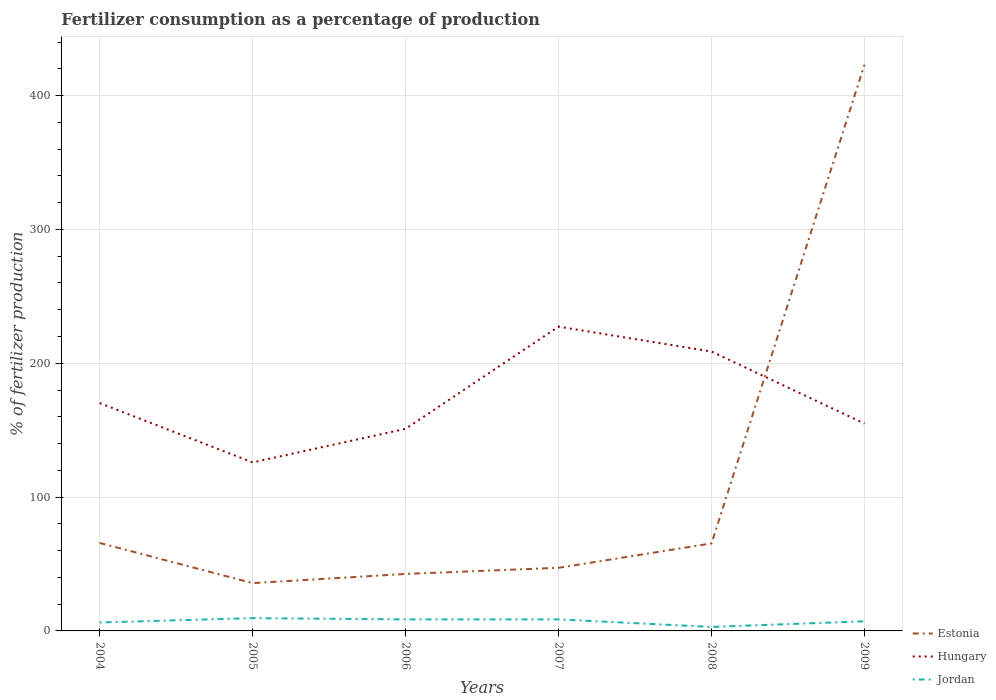How many different coloured lines are there?
Offer a very short reply. 3. Does the line corresponding to Jordan intersect with the line corresponding to Estonia?
Offer a terse response. No. Is the number of lines equal to the number of legend labels?
Provide a short and direct response. Yes. Across all years, what is the maximum percentage of fertilizers consumed in Estonia?
Offer a very short reply. 35.72. What is the total percentage of fertilizers consumed in Jordan in the graph?
Keep it short and to the point. -3.25. What is the difference between the highest and the second highest percentage of fertilizers consumed in Estonia?
Ensure brevity in your answer.  387.4. How many lines are there?
Provide a succinct answer. 3. What is the difference between two consecutive major ticks on the Y-axis?
Offer a very short reply. 100. Are the values on the major ticks of Y-axis written in scientific E-notation?
Your answer should be very brief. No. What is the title of the graph?
Keep it short and to the point. Fertilizer consumption as a percentage of production. Does "Egypt, Arab Rep." appear as one of the legend labels in the graph?
Make the answer very short. No. What is the label or title of the X-axis?
Your response must be concise. Years. What is the label or title of the Y-axis?
Offer a very short reply. % of fertilizer production. What is the % of fertilizer production of Estonia in 2004?
Offer a very short reply. 65.74. What is the % of fertilizer production of Hungary in 2004?
Keep it short and to the point. 170.26. What is the % of fertilizer production of Jordan in 2004?
Give a very brief answer. 6.31. What is the % of fertilizer production of Estonia in 2005?
Provide a short and direct response. 35.72. What is the % of fertilizer production in Hungary in 2005?
Your answer should be very brief. 125.92. What is the % of fertilizer production in Jordan in 2005?
Your answer should be very brief. 9.56. What is the % of fertilizer production in Estonia in 2006?
Your answer should be compact. 42.57. What is the % of fertilizer production of Hungary in 2006?
Your response must be concise. 150.99. What is the % of fertilizer production of Jordan in 2006?
Your answer should be very brief. 8.61. What is the % of fertilizer production in Estonia in 2007?
Offer a very short reply. 47.17. What is the % of fertilizer production of Hungary in 2007?
Keep it short and to the point. 227.39. What is the % of fertilizer production of Jordan in 2007?
Offer a very short reply. 8.6. What is the % of fertilizer production of Estonia in 2008?
Provide a succinct answer. 65.39. What is the % of fertilizer production in Hungary in 2008?
Provide a succinct answer. 208.76. What is the % of fertilizer production of Jordan in 2008?
Provide a succinct answer. 2.99. What is the % of fertilizer production in Estonia in 2009?
Your answer should be very brief. 423.12. What is the % of fertilizer production of Hungary in 2009?
Give a very brief answer. 154.95. What is the % of fertilizer production of Jordan in 2009?
Your response must be concise. 7.18. Across all years, what is the maximum % of fertilizer production of Estonia?
Your response must be concise. 423.12. Across all years, what is the maximum % of fertilizer production of Hungary?
Make the answer very short. 227.39. Across all years, what is the maximum % of fertilizer production in Jordan?
Offer a terse response. 9.56. Across all years, what is the minimum % of fertilizer production in Estonia?
Keep it short and to the point. 35.72. Across all years, what is the minimum % of fertilizer production in Hungary?
Offer a very short reply. 125.92. Across all years, what is the minimum % of fertilizer production of Jordan?
Provide a short and direct response. 2.99. What is the total % of fertilizer production of Estonia in the graph?
Provide a short and direct response. 679.71. What is the total % of fertilizer production of Hungary in the graph?
Your answer should be compact. 1038.27. What is the total % of fertilizer production in Jordan in the graph?
Offer a terse response. 43.25. What is the difference between the % of fertilizer production in Estonia in 2004 and that in 2005?
Provide a succinct answer. 30.02. What is the difference between the % of fertilizer production in Hungary in 2004 and that in 2005?
Your response must be concise. 44.33. What is the difference between the % of fertilizer production in Jordan in 2004 and that in 2005?
Your answer should be compact. -3.25. What is the difference between the % of fertilizer production of Estonia in 2004 and that in 2006?
Your answer should be very brief. 23.16. What is the difference between the % of fertilizer production in Hungary in 2004 and that in 2006?
Your response must be concise. 19.26. What is the difference between the % of fertilizer production in Jordan in 2004 and that in 2006?
Make the answer very short. -2.3. What is the difference between the % of fertilizer production of Estonia in 2004 and that in 2007?
Your response must be concise. 18.57. What is the difference between the % of fertilizer production in Hungary in 2004 and that in 2007?
Your response must be concise. -57.13. What is the difference between the % of fertilizer production of Jordan in 2004 and that in 2007?
Ensure brevity in your answer.  -2.29. What is the difference between the % of fertilizer production in Estonia in 2004 and that in 2008?
Provide a short and direct response. 0.35. What is the difference between the % of fertilizer production in Hungary in 2004 and that in 2008?
Ensure brevity in your answer.  -38.5. What is the difference between the % of fertilizer production of Jordan in 2004 and that in 2008?
Your response must be concise. 3.32. What is the difference between the % of fertilizer production in Estonia in 2004 and that in 2009?
Keep it short and to the point. -357.38. What is the difference between the % of fertilizer production of Hungary in 2004 and that in 2009?
Provide a short and direct response. 15.3. What is the difference between the % of fertilizer production of Jordan in 2004 and that in 2009?
Offer a terse response. -0.87. What is the difference between the % of fertilizer production in Estonia in 2005 and that in 2006?
Offer a terse response. -6.86. What is the difference between the % of fertilizer production of Hungary in 2005 and that in 2006?
Your answer should be compact. -25.07. What is the difference between the % of fertilizer production of Jordan in 2005 and that in 2006?
Make the answer very short. 0.94. What is the difference between the % of fertilizer production of Estonia in 2005 and that in 2007?
Give a very brief answer. -11.45. What is the difference between the % of fertilizer production of Hungary in 2005 and that in 2007?
Provide a succinct answer. -101.46. What is the difference between the % of fertilizer production in Jordan in 2005 and that in 2007?
Offer a terse response. 0.95. What is the difference between the % of fertilizer production in Estonia in 2005 and that in 2008?
Keep it short and to the point. -29.67. What is the difference between the % of fertilizer production of Hungary in 2005 and that in 2008?
Your response must be concise. -82.83. What is the difference between the % of fertilizer production of Jordan in 2005 and that in 2008?
Ensure brevity in your answer.  6.56. What is the difference between the % of fertilizer production in Estonia in 2005 and that in 2009?
Provide a succinct answer. -387.4. What is the difference between the % of fertilizer production of Hungary in 2005 and that in 2009?
Offer a terse response. -29.03. What is the difference between the % of fertilizer production in Jordan in 2005 and that in 2009?
Make the answer very short. 2.38. What is the difference between the % of fertilizer production in Estonia in 2006 and that in 2007?
Offer a terse response. -4.59. What is the difference between the % of fertilizer production of Hungary in 2006 and that in 2007?
Provide a succinct answer. -76.39. What is the difference between the % of fertilizer production in Jordan in 2006 and that in 2007?
Provide a succinct answer. 0.01. What is the difference between the % of fertilizer production of Estonia in 2006 and that in 2008?
Provide a short and direct response. -22.82. What is the difference between the % of fertilizer production in Hungary in 2006 and that in 2008?
Provide a short and direct response. -57.76. What is the difference between the % of fertilizer production in Jordan in 2006 and that in 2008?
Offer a very short reply. 5.62. What is the difference between the % of fertilizer production of Estonia in 2006 and that in 2009?
Ensure brevity in your answer.  -380.54. What is the difference between the % of fertilizer production in Hungary in 2006 and that in 2009?
Provide a short and direct response. -3.96. What is the difference between the % of fertilizer production in Jordan in 2006 and that in 2009?
Your response must be concise. 1.43. What is the difference between the % of fertilizer production of Estonia in 2007 and that in 2008?
Your answer should be very brief. -18.23. What is the difference between the % of fertilizer production in Hungary in 2007 and that in 2008?
Your answer should be very brief. 18.63. What is the difference between the % of fertilizer production of Jordan in 2007 and that in 2008?
Provide a short and direct response. 5.61. What is the difference between the % of fertilizer production of Estonia in 2007 and that in 2009?
Ensure brevity in your answer.  -375.95. What is the difference between the % of fertilizer production in Hungary in 2007 and that in 2009?
Provide a short and direct response. 72.43. What is the difference between the % of fertilizer production of Jordan in 2007 and that in 2009?
Keep it short and to the point. 1.42. What is the difference between the % of fertilizer production of Estonia in 2008 and that in 2009?
Offer a terse response. -357.73. What is the difference between the % of fertilizer production in Hungary in 2008 and that in 2009?
Offer a very short reply. 53.8. What is the difference between the % of fertilizer production in Jordan in 2008 and that in 2009?
Make the answer very short. -4.19. What is the difference between the % of fertilizer production in Estonia in 2004 and the % of fertilizer production in Hungary in 2005?
Provide a succinct answer. -60.19. What is the difference between the % of fertilizer production of Estonia in 2004 and the % of fertilizer production of Jordan in 2005?
Keep it short and to the point. 56.18. What is the difference between the % of fertilizer production in Hungary in 2004 and the % of fertilizer production in Jordan in 2005?
Ensure brevity in your answer.  160.7. What is the difference between the % of fertilizer production in Estonia in 2004 and the % of fertilizer production in Hungary in 2006?
Provide a succinct answer. -85.26. What is the difference between the % of fertilizer production in Estonia in 2004 and the % of fertilizer production in Jordan in 2006?
Keep it short and to the point. 57.12. What is the difference between the % of fertilizer production in Hungary in 2004 and the % of fertilizer production in Jordan in 2006?
Make the answer very short. 161.64. What is the difference between the % of fertilizer production in Estonia in 2004 and the % of fertilizer production in Hungary in 2007?
Provide a short and direct response. -161.65. What is the difference between the % of fertilizer production of Estonia in 2004 and the % of fertilizer production of Jordan in 2007?
Offer a terse response. 57.14. What is the difference between the % of fertilizer production in Hungary in 2004 and the % of fertilizer production in Jordan in 2007?
Provide a short and direct response. 161.65. What is the difference between the % of fertilizer production in Estonia in 2004 and the % of fertilizer production in Hungary in 2008?
Offer a terse response. -143.02. What is the difference between the % of fertilizer production in Estonia in 2004 and the % of fertilizer production in Jordan in 2008?
Your answer should be compact. 62.74. What is the difference between the % of fertilizer production in Hungary in 2004 and the % of fertilizer production in Jordan in 2008?
Give a very brief answer. 167.26. What is the difference between the % of fertilizer production in Estonia in 2004 and the % of fertilizer production in Hungary in 2009?
Keep it short and to the point. -89.21. What is the difference between the % of fertilizer production in Estonia in 2004 and the % of fertilizer production in Jordan in 2009?
Offer a very short reply. 58.56. What is the difference between the % of fertilizer production of Hungary in 2004 and the % of fertilizer production of Jordan in 2009?
Ensure brevity in your answer.  163.08. What is the difference between the % of fertilizer production of Estonia in 2005 and the % of fertilizer production of Hungary in 2006?
Your response must be concise. -115.27. What is the difference between the % of fertilizer production of Estonia in 2005 and the % of fertilizer production of Jordan in 2006?
Make the answer very short. 27.11. What is the difference between the % of fertilizer production of Hungary in 2005 and the % of fertilizer production of Jordan in 2006?
Make the answer very short. 117.31. What is the difference between the % of fertilizer production in Estonia in 2005 and the % of fertilizer production in Hungary in 2007?
Your response must be concise. -191.67. What is the difference between the % of fertilizer production of Estonia in 2005 and the % of fertilizer production of Jordan in 2007?
Make the answer very short. 27.12. What is the difference between the % of fertilizer production of Hungary in 2005 and the % of fertilizer production of Jordan in 2007?
Ensure brevity in your answer.  117.32. What is the difference between the % of fertilizer production in Estonia in 2005 and the % of fertilizer production in Hungary in 2008?
Offer a terse response. -173.04. What is the difference between the % of fertilizer production of Estonia in 2005 and the % of fertilizer production of Jordan in 2008?
Offer a terse response. 32.73. What is the difference between the % of fertilizer production in Hungary in 2005 and the % of fertilizer production in Jordan in 2008?
Your answer should be very brief. 122.93. What is the difference between the % of fertilizer production in Estonia in 2005 and the % of fertilizer production in Hungary in 2009?
Keep it short and to the point. -119.23. What is the difference between the % of fertilizer production in Estonia in 2005 and the % of fertilizer production in Jordan in 2009?
Your answer should be very brief. 28.54. What is the difference between the % of fertilizer production in Hungary in 2005 and the % of fertilizer production in Jordan in 2009?
Make the answer very short. 118.74. What is the difference between the % of fertilizer production of Estonia in 2006 and the % of fertilizer production of Hungary in 2007?
Offer a very short reply. -184.81. What is the difference between the % of fertilizer production of Estonia in 2006 and the % of fertilizer production of Jordan in 2007?
Make the answer very short. 33.97. What is the difference between the % of fertilizer production of Hungary in 2006 and the % of fertilizer production of Jordan in 2007?
Provide a succinct answer. 142.39. What is the difference between the % of fertilizer production in Estonia in 2006 and the % of fertilizer production in Hungary in 2008?
Make the answer very short. -166.18. What is the difference between the % of fertilizer production in Estonia in 2006 and the % of fertilizer production in Jordan in 2008?
Your response must be concise. 39.58. What is the difference between the % of fertilizer production in Hungary in 2006 and the % of fertilizer production in Jordan in 2008?
Provide a succinct answer. 148. What is the difference between the % of fertilizer production in Estonia in 2006 and the % of fertilizer production in Hungary in 2009?
Give a very brief answer. -112.38. What is the difference between the % of fertilizer production of Estonia in 2006 and the % of fertilizer production of Jordan in 2009?
Your answer should be very brief. 35.4. What is the difference between the % of fertilizer production of Hungary in 2006 and the % of fertilizer production of Jordan in 2009?
Provide a succinct answer. 143.81. What is the difference between the % of fertilizer production of Estonia in 2007 and the % of fertilizer production of Hungary in 2008?
Ensure brevity in your answer.  -161.59. What is the difference between the % of fertilizer production of Estonia in 2007 and the % of fertilizer production of Jordan in 2008?
Provide a succinct answer. 44.17. What is the difference between the % of fertilizer production in Hungary in 2007 and the % of fertilizer production in Jordan in 2008?
Offer a very short reply. 224.39. What is the difference between the % of fertilizer production in Estonia in 2007 and the % of fertilizer production in Hungary in 2009?
Ensure brevity in your answer.  -107.79. What is the difference between the % of fertilizer production in Estonia in 2007 and the % of fertilizer production in Jordan in 2009?
Make the answer very short. 39.99. What is the difference between the % of fertilizer production of Hungary in 2007 and the % of fertilizer production of Jordan in 2009?
Offer a very short reply. 220.21. What is the difference between the % of fertilizer production of Estonia in 2008 and the % of fertilizer production of Hungary in 2009?
Your response must be concise. -89.56. What is the difference between the % of fertilizer production of Estonia in 2008 and the % of fertilizer production of Jordan in 2009?
Your answer should be very brief. 58.21. What is the difference between the % of fertilizer production of Hungary in 2008 and the % of fertilizer production of Jordan in 2009?
Ensure brevity in your answer.  201.58. What is the average % of fertilizer production of Estonia per year?
Offer a terse response. 113.28. What is the average % of fertilizer production of Hungary per year?
Provide a short and direct response. 173.04. What is the average % of fertilizer production of Jordan per year?
Provide a short and direct response. 7.21. In the year 2004, what is the difference between the % of fertilizer production in Estonia and % of fertilizer production in Hungary?
Offer a terse response. -104.52. In the year 2004, what is the difference between the % of fertilizer production of Estonia and % of fertilizer production of Jordan?
Keep it short and to the point. 59.43. In the year 2004, what is the difference between the % of fertilizer production of Hungary and % of fertilizer production of Jordan?
Offer a terse response. 163.95. In the year 2005, what is the difference between the % of fertilizer production in Estonia and % of fertilizer production in Hungary?
Provide a short and direct response. -90.2. In the year 2005, what is the difference between the % of fertilizer production in Estonia and % of fertilizer production in Jordan?
Give a very brief answer. 26.16. In the year 2005, what is the difference between the % of fertilizer production in Hungary and % of fertilizer production in Jordan?
Provide a short and direct response. 116.37. In the year 2006, what is the difference between the % of fertilizer production in Estonia and % of fertilizer production in Hungary?
Your response must be concise. -108.42. In the year 2006, what is the difference between the % of fertilizer production of Estonia and % of fertilizer production of Jordan?
Your answer should be very brief. 33.96. In the year 2006, what is the difference between the % of fertilizer production of Hungary and % of fertilizer production of Jordan?
Your answer should be compact. 142.38. In the year 2007, what is the difference between the % of fertilizer production of Estonia and % of fertilizer production of Hungary?
Offer a terse response. -180.22. In the year 2007, what is the difference between the % of fertilizer production of Estonia and % of fertilizer production of Jordan?
Your answer should be very brief. 38.56. In the year 2007, what is the difference between the % of fertilizer production of Hungary and % of fertilizer production of Jordan?
Your response must be concise. 218.78. In the year 2008, what is the difference between the % of fertilizer production in Estonia and % of fertilizer production in Hungary?
Your response must be concise. -143.37. In the year 2008, what is the difference between the % of fertilizer production of Estonia and % of fertilizer production of Jordan?
Offer a terse response. 62.4. In the year 2008, what is the difference between the % of fertilizer production in Hungary and % of fertilizer production in Jordan?
Provide a succinct answer. 205.76. In the year 2009, what is the difference between the % of fertilizer production of Estonia and % of fertilizer production of Hungary?
Ensure brevity in your answer.  268.17. In the year 2009, what is the difference between the % of fertilizer production in Estonia and % of fertilizer production in Jordan?
Give a very brief answer. 415.94. In the year 2009, what is the difference between the % of fertilizer production of Hungary and % of fertilizer production of Jordan?
Offer a terse response. 147.77. What is the ratio of the % of fertilizer production in Estonia in 2004 to that in 2005?
Your answer should be very brief. 1.84. What is the ratio of the % of fertilizer production of Hungary in 2004 to that in 2005?
Make the answer very short. 1.35. What is the ratio of the % of fertilizer production in Jordan in 2004 to that in 2005?
Make the answer very short. 0.66. What is the ratio of the % of fertilizer production of Estonia in 2004 to that in 2006?
Give a very brief answer. 1.54. What is the ratio of the % of fertilizer production in Hungary in 2004 to that in 2006?
Ensure brevity in your answer.  1.13. What is the ratio of the % of fertilizer production of Jordan in 2004 to that in 2006?
Keep it short and to the point. 0.73. What is the ratio of the % of fertilizer production in Estonia in 2004 to that in 2007?
Make the answer very short. 1.39. What is the ratio of the % of fertilizer production of Hungary in 2004 to that in 2007?
Your answer should be compact. 0.75. What is the ratio of the % of fertilizer production of Jordan in 2004 to that in 2007?
Your response must be concise. 0.73. What is the ratio of the % of fertilizer production of Hungary in 2004 to that in 2008?
Ensure brevity in your answer.  0.82. What is the ratio of the % of fertilizer production of Jordan in 2004 to that in 2008?
Your answer should be very brief. 2.11. What is the ratio of the % of fertilizer production of Estonia in 2004 to that in 2009?
Provide a short and direct response. 0.16. What is the ratio of the % of fertilizer production of Hungary in 2004 to that in 2009?
Your answer should be very brief. 1.1. What is the ratio of the % of fertilizer production of Jordan in 2004 to that in 2009?
Make the answer very short. 0.88. What is the ratio of the % of fertilizer production in Estonia in 2005 to that in 2006?
Make the answer very short. 0.84. What is the ratio of the % of fertilizer production of Hungary in 2005 to that in 2006?
Offer a terse response. 0.83. What is the ratio of the % of fertilizer production of Jordan in 2005 to that in 2006?
Make the answer very short. 1.11. What is the ratio of the % of fertilizer production in Estonia in 2005 to that in 2007?
Provide a short and direct response. 0.76. What is the ratio of the % of fertilizer production in Hungary in 2005 to that in 2007?
Give a very brief answer. 0.55. What is the ratio of the % of fertilizer production of Jordan in 2005 to that in 2007?
Provide a succinct answer. 1.11. What is the ratio of the % of fertilizer production in Estonia in 2005 to that in 2008?
Your response must be concise. 0.55. What is the ratio of the % of fertilizer production of Hungary in 2005 to that in 2008?
Your answer should be very brief. 0.6. What is the ratio of the % of fertilizer production in Jordan in 2005 to that in 2008?
Provide a short and direct response. 3.19. What is the ratio of the % of fertilizer production of Estonia in 2005 to that in 2009?
Provide a succinct answer. 0.08. What is the ratio of the % of fertilizer production in Hungary in 2005 to that in 2009?
Offer a terse response. 0.81. What is the ratio of the % of fertilizer production of Jordan in 2005 to that in 2009?
Provide a short and direct response. 1.33. What is the ratio of the % of fertilizer production in Estonia in 2006 to that in 2007?
Offer a very short reply. 0.9. What is the ratio of the % of fertilizer production in Hungary in 2006 to that in 2007?
Your answer should be very brief. 0.66. What is the ratio of the % of fertilizer production in Jordan in 2006 to that in 2007?
Ensure brevity in your answer.  1. What is the ratio of the % of fertilizer production in Estonia in 2006 to that in 2008?
Your answer should be compact. 0.65. What is the ratio of the % of fertilizer production of Hungary in 2006 to that in 2008?
Provide a short and direct response. 0.72. What is the ratio of the % of fertilizer production of Jordan in 2006 to that in 2008?
Your answer should be very brief. 2.88. What is the ratio of the % of fertilizer production of Estonia in 2006 to that in 2009?
Offer a terse response. 0.1. What is the ratio of the % of fertilizer production in Hungary in 2006 to that in 2009?
Give a very brief answer. 0.97. What is the ratio of the % of fertilizer production of Jordan in 2006 to that in 2009?
Your response must be concise. 1.2. What is the ratio of the % of fertilizer production of Estonia in 2007 to that in 2008?
Make the answer very short. 0.72. What is the ratio of the % of fertilizer production in Hungary in 2007 to that in 2008?
Ensure brevity in your answer.  1.09. What is the ratio of the % of fertilizer production in Jordan in 2007 to that in 2008?
Your answer should be very brief. 2.87. What is the ratio of the % of fertilizer production in Estonia in 2007 to that in 2009?
Make the answer very short. 0.11. What is the ratio of the % of fertilizer production of Hungary in 2007 to that in 2009?
Give a very brief answer. 1.47. What is the ratio of the % of fertilizer production of Jordan in 2007 to that in 2009?
Provide a succinct answer. 1.2. What is the ratio of the % of fertilizer production of Estonia in 2008 to that in 2009?
Ensure brevity in your answer.  0.15. What is the ratio of the % of fertilizer production of Hungary in 2008 to that in 2009?
Offer a terse response. 1.35. What is the ratio of the % of fertilizer production in Jordan in 2008 to that in 2009?
Your answer should be compact. 0.42. What is the difference between the highest and the second highest % of fertilizer production of Estonia?
Ensure brevity in your answer.  357.38. What is the difference between the highest and the second highest % of fertilizer production of Hungary?
Ensure brevity in your answer.  18.63. What is the difference between the highest and the second highest % of fertilizer production of Jordan?
Make the answer very short. 0.94. What is the difference between the highest and the lowest % of fertilizer production in Estonia?
Keep it short and to the point. 387.4. What is the difference between the highest and the lowest % of fertilizer production of Hungary?
Offer a terse response. 101.46. What is the difference between the highest and the lowest % of fertilizer production in Jordan?
Offer a terse response. 6.56. 